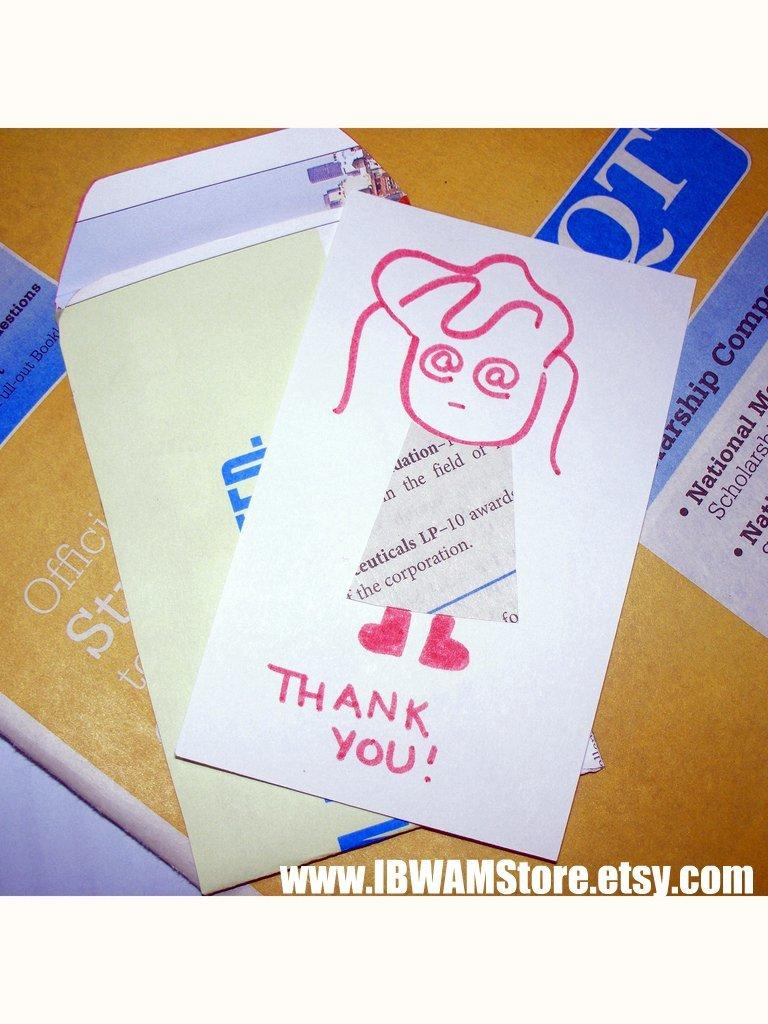<image>
Describe the image concisely. cards on a table and one is a weird red girl that reads Thank You! 